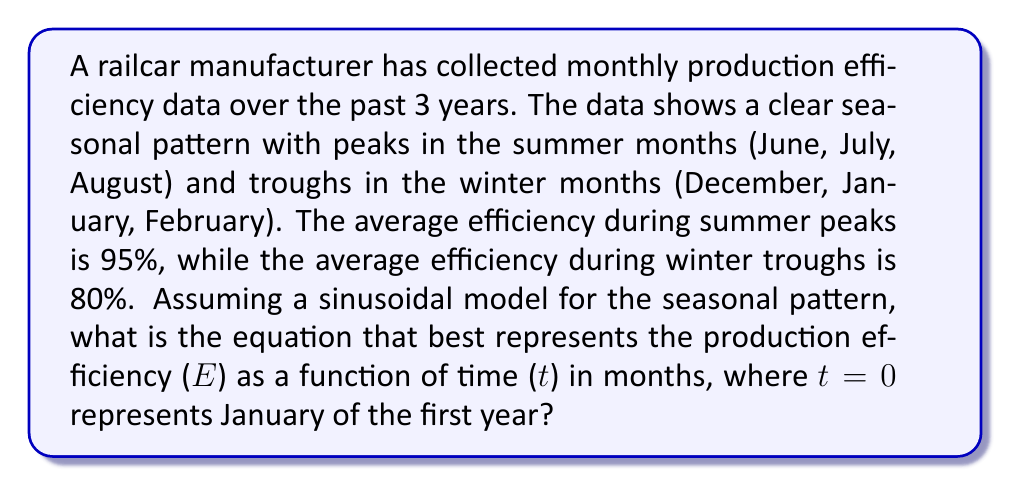What is the answer to this math problem? To model this seasonal pattern using a sinusoidal function, we need to determine the amplitude, period, vertical shift, and phase shift of the function. Let's approach this step-by-step:

1. Amplitude: The amplitude is half the difference between the peak and trough values.
   $A = \frac{95\% - 80\%}{2} = 7.5\%$

2. Period: The period is 12 months (1 year).
   $P = 12$

3. Vertical shift: This is the average of the peak and trough values.
   $C = \frac{95\% + 80\%}{2} = 87.5\%$

4. Phase shift: The peak occurs in the summer (July, or t = 6), so we need to shift the cosine function by 6 months.

The general form of a sinusoidal function is:

$$ E(t) = A \cos(\frac{2\pi}{P}(t-h)) + C $$

Where:
- $A$ is the amplitude
- $P$ is the period
- $h$ is the horizontal shift
- $C$ is the vertical shift

Substituting our values:

$$ E(t) = 7.5\% \cos(\frac{2\pi}{12}(t-6)) + 87.5\% $$

Simplifying:

$$ E(t) = 7.5\% \cos(\frac{\pi}{6}(t-6)) + 87.5\% $$

This can be rewritten as:

$$ E(t) = 7.5\% \cos(\frac{\pi t}{6} - \pi) + 87.5\% $$

Using the cosine angle addition formula, we can further simplify:

$$ E(t) = -7.5\% \cos(\frac{\pi t}{6}) + 87.5\% $$

This is the final equation representing the production efficiency as a function of time.
Answer: $$ E(t) = -7.5\% \cos(\frac{\pi t}{6}) + 87.5\% $$ 